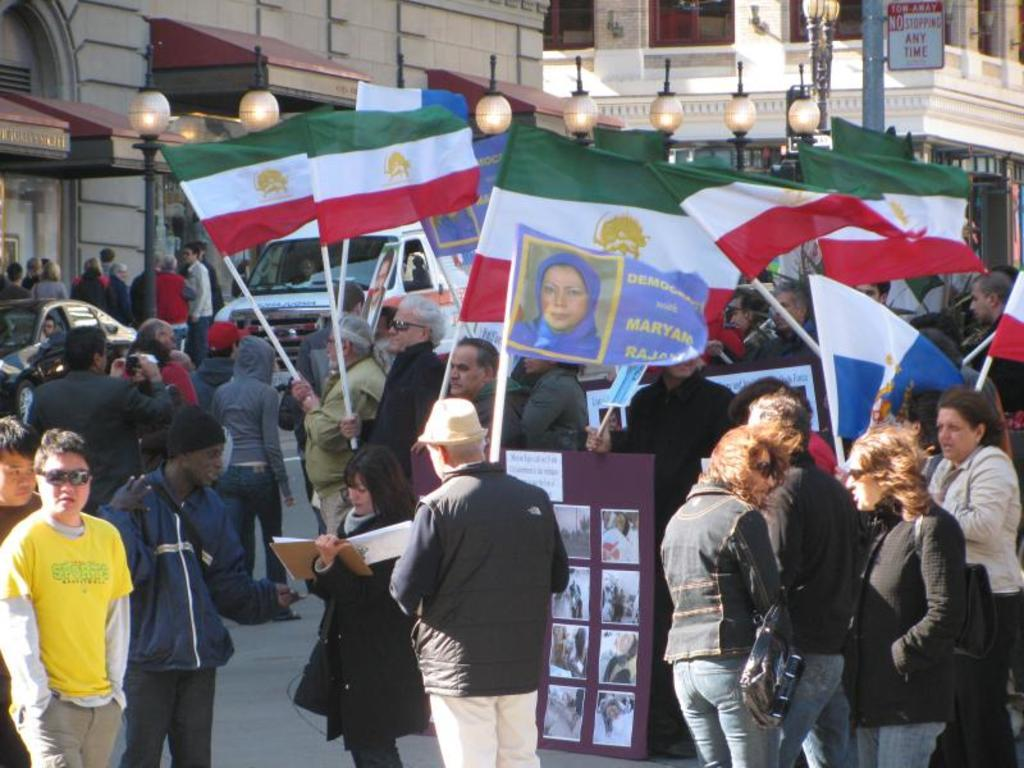How many people are in the image? There is a group of people in the image, but the exact number cannot be determined from the provided facts. What are some people doing in the image? Some people are holding flags in the image. What can be seen in the background of the image? There are lights, poles, buildings, and vehicles in the background of the image. What type of paste is being used to stick the bears to the poles in the image? There are no bears present in the image, and therefore no paste or sticking activity can be observed. 